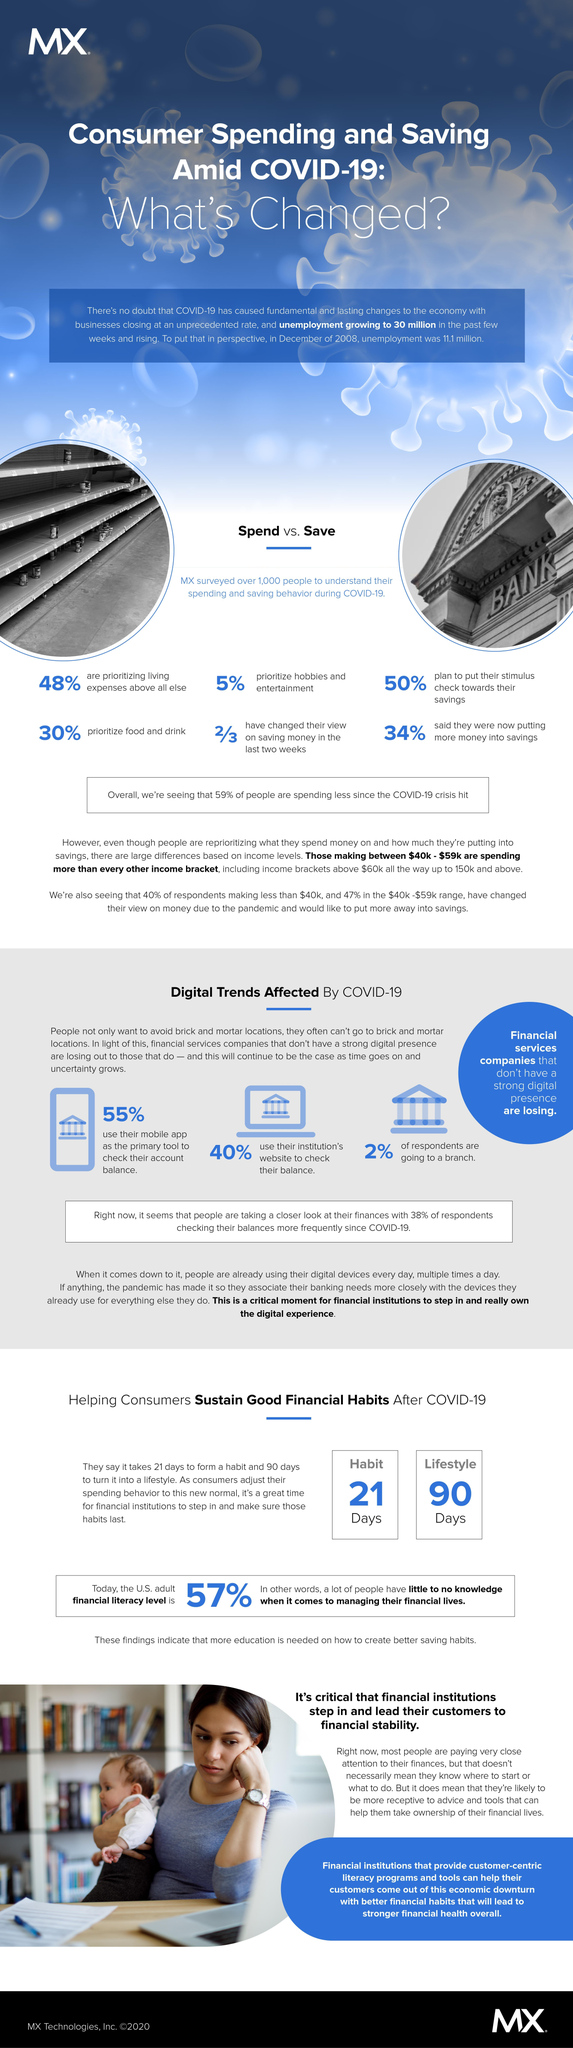What percentage of people are putting more money into savings amid Covid-19?
Answer the question with a short phrase. 34% What percentage of people do not prioritize food & drink amid Covid-19? 70% What percentage of people do not prioritize hobbies & entertainment during Covid-19? 95% What percentage of people use their institution's website to check their balance amid Covid-19? 40% What percentage of people do not use their mobile app as the primary tool to check their account balance amid Covid-19? 45% 